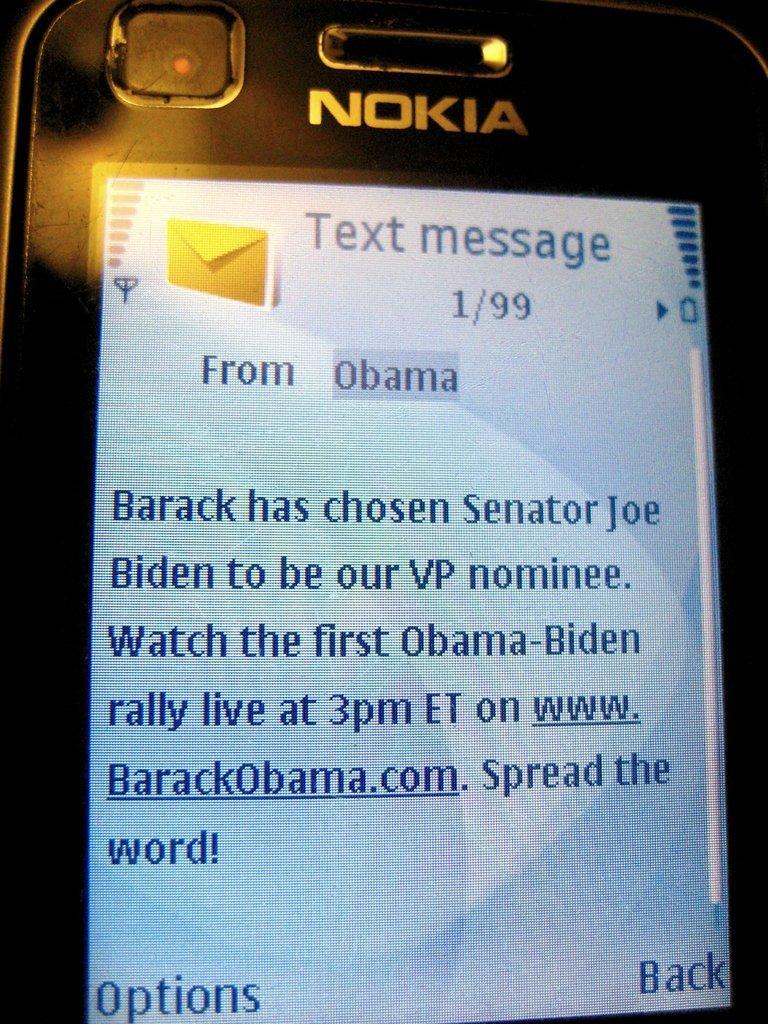Describe this image in one or two sentences. In the image we can see a mobile phone screen. 